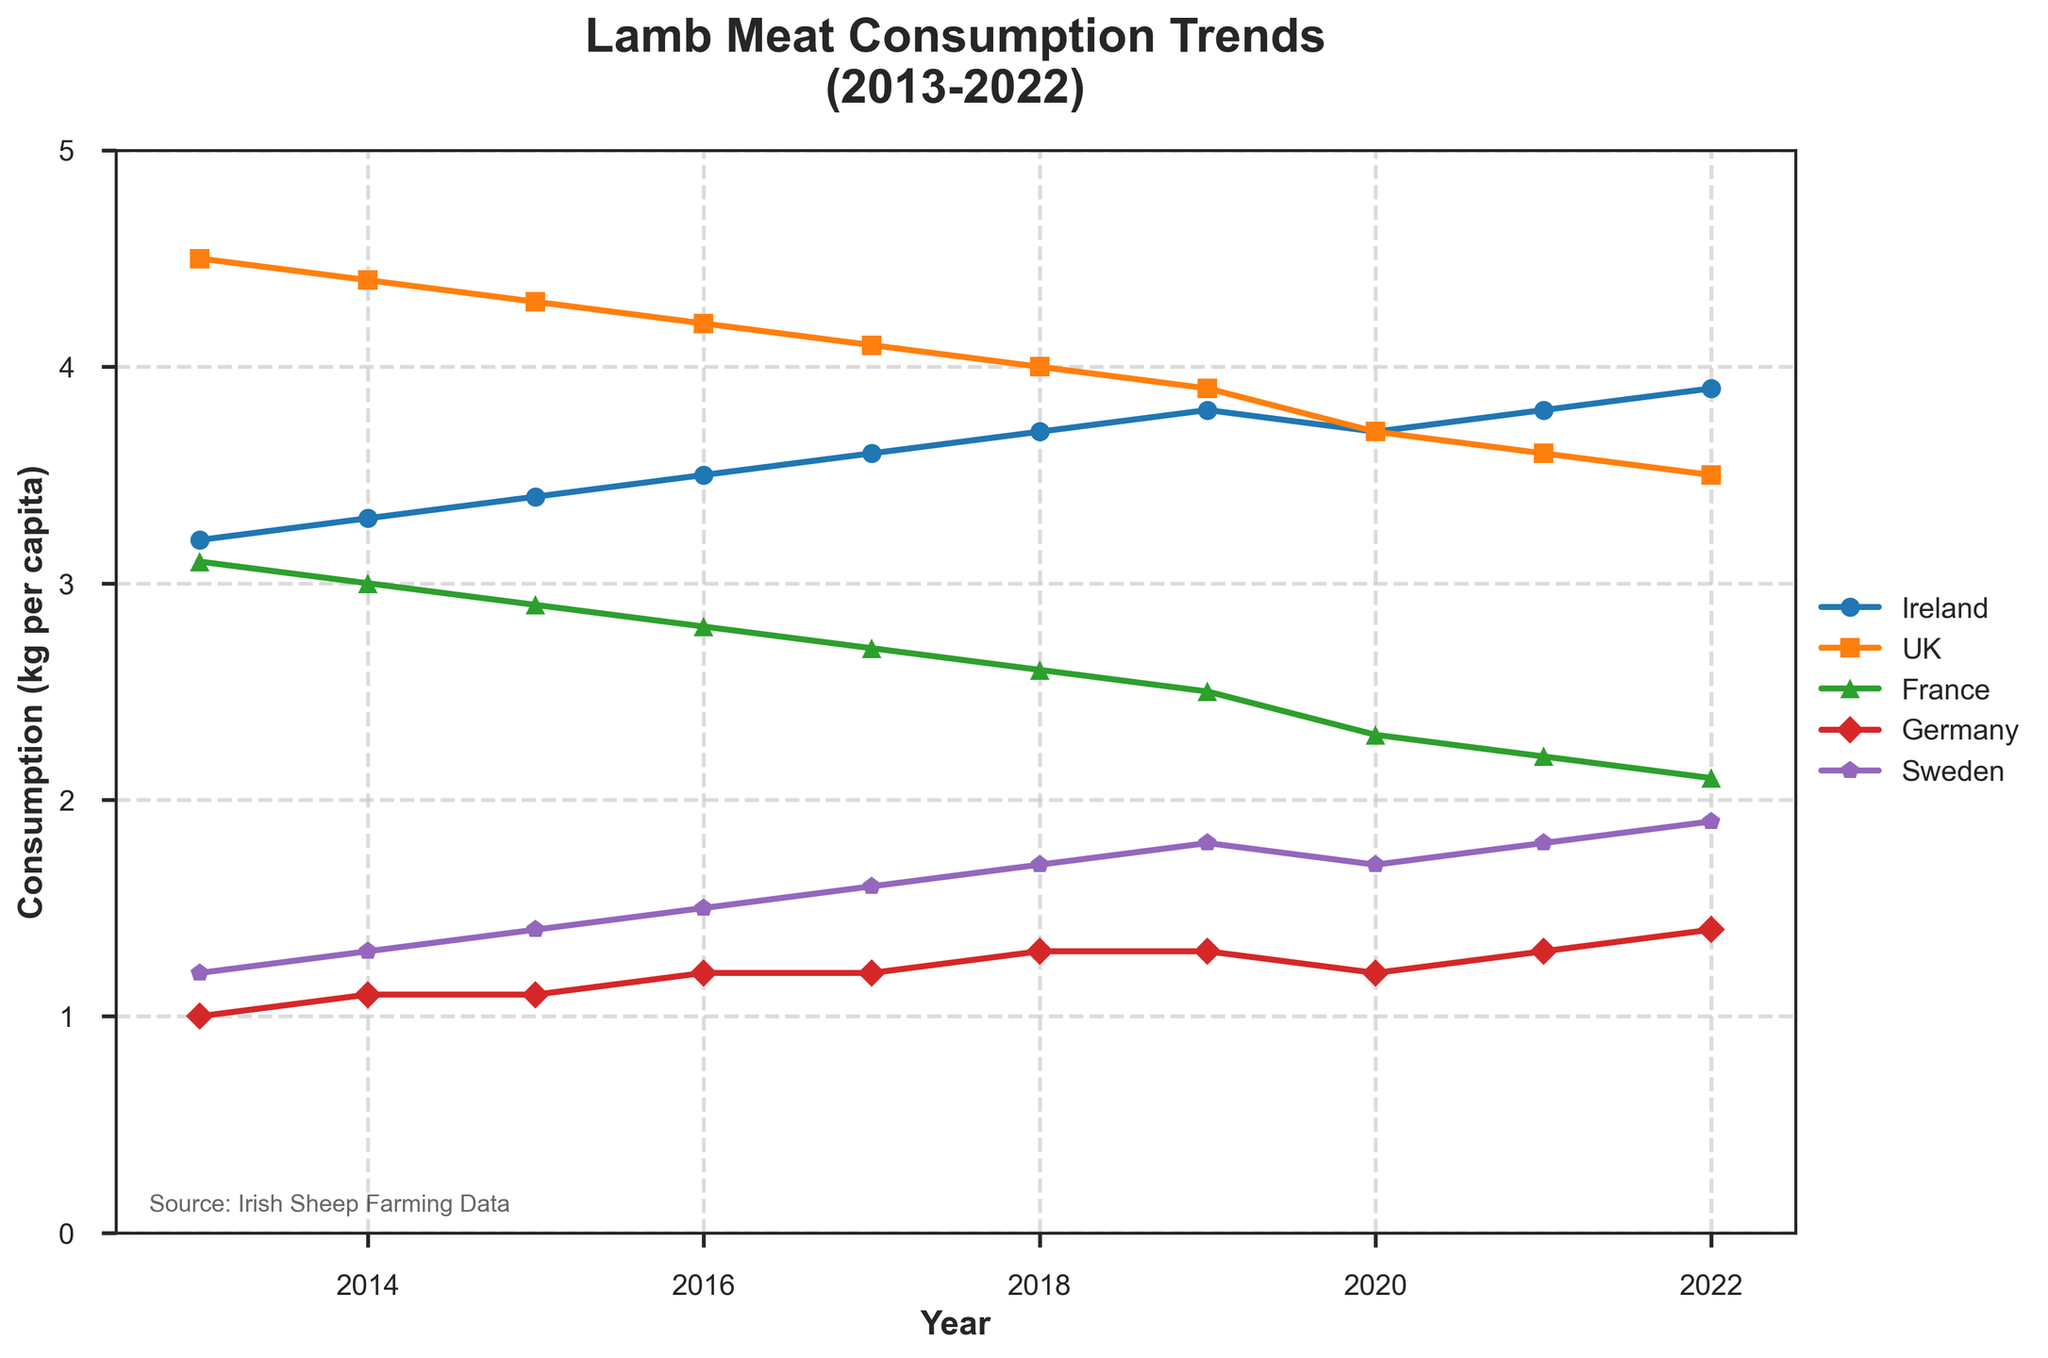What is the yearly trend of lamb meat consumption in Ireland from 2013 to 2022? The trend shows a gradual increase in lamb meat consumption in Ireland from 3.2 kg per capita in 2013 to 3.9 kg per capita in 2022.
Answer: Gradual increase Which country had the highest lamb meat consumption per capita in 2013? From the figure, the UK had the highest lamb meat consumption at 4.5 kg per capita in 2013.
Answer: UK Between 2014 and 2018, how did the lamb meat consumption trend in France change? The consumption in France shows a consistent decrease from 3.0 kg per capita in 2014 to 2.6 kg per capita in 2018.
Answer: Consistent decrease In which year did Germany see the highest lamb meat consumption, and what was the value? Germany saw the highest lamb meat consumption in 2022 with 1.4 kg per capita.
Answer: 2022, 1.4 kg Comparing the lamb meat consumption in Ireland and the UK in 2020, which country had lower consumption? In 2020, Ireland had a higher consumption (3.7 kg per capita) compared to the UK (3.7 kg per capita).
Answer: UK Calculate the average lamb meat consumption in Sweden from 2013 to 2022. The average consumption is computed by summing all the data points for Sweden (1.2 + 1.3 + 1.4 + 1.5 + 1.6 + 1.7 + 1.8 + 1.7 + 1.8 + 1.9) which gives 15.9, then dividing by the number of years, 10. Average = 15.9 / 10 = 1.59 kg per capita.
Answer: 1.59 kg What is the overall trend of lamb meat consumption in the UK from 2013 to 2022? The trend in the UK shows a steady decrease in lamb meat consumption from 4.5 kg per capita in 2013 to 3.5 kg per capita in 2022.
Answer: Steady decrease In 2016, how did the lamb meat consumption in Ireland compare to that in France? In 2016, Ireland's consumption was 3.5 kg per capita, while France's consumption was 2.8 kg per capita.
Answer: Higher in Ireland Identify the year in which the lamb meat consumption in Ireland surpassed 3.5 kg per capita. The consumption in Ireland surpassed 3.5 kg per capita in 2017.
Answer: 2017 Which country had the least fluctuation in lamb meat consumption over the decade? Sweden had the least fluctuation, showing a steady increase from 1.2 kg per capita in 2013 to 1.9 kg per capita in 2022 without significant drops.
Answer: Sweden 